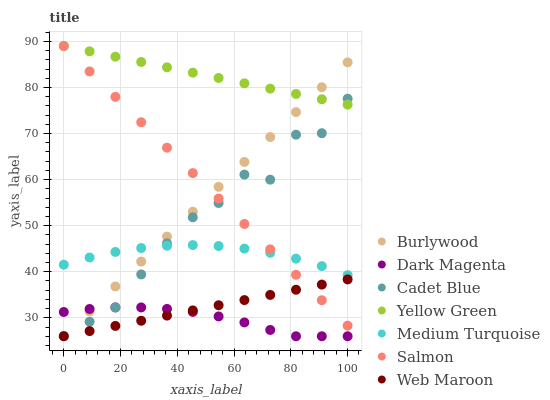Does Dark Magenta have the minimum area under the curve?
Answer yes or no. Yes. Does Yellow Green have the maximum area under the curve?
Answer yes or no. Yes. Does Burlywood have the minimum area under the curve?
Answer yes or no. No. Does Burlywood have the maximum area under the curve?
Answer yes or no. No. Is Web Maroon the smoothest?
Answer yes or no. Yes. Is Cadet Blue the roughest?
Answer yes or no. Yes. Is Dark Magenta the smoothest?
Answer yes or no. No. Is Dark Magenta the roughest?
Answer yes or no. No. Does Dark Magenta have the lowest value?
Answer yes or no. Yes. Does Salmon have the lowest value?
Answer yes or no. No. Does Yellow Green have the highest value?
Answer yes or no. Yes. Does Burlywood have the highest value?
Answer yes or no. No. Is Dark Magenta less than Salmon?
Answer yes or no. Yes. Is Cadet Blue greater than Web Maroon?
Answer yes or no. Yes. Does Cadet Blue intersect Medium Turquoise?
Answer yes or no. Yes. Is Cadet Blue less than Medium Turquoise?
Answer yes or no. No. Is Cadet Blue greater than Medium Turquoise?
Answer yes or no. No. Does Dark Magenta intersect Salmon?
Answer yes or no. No. 